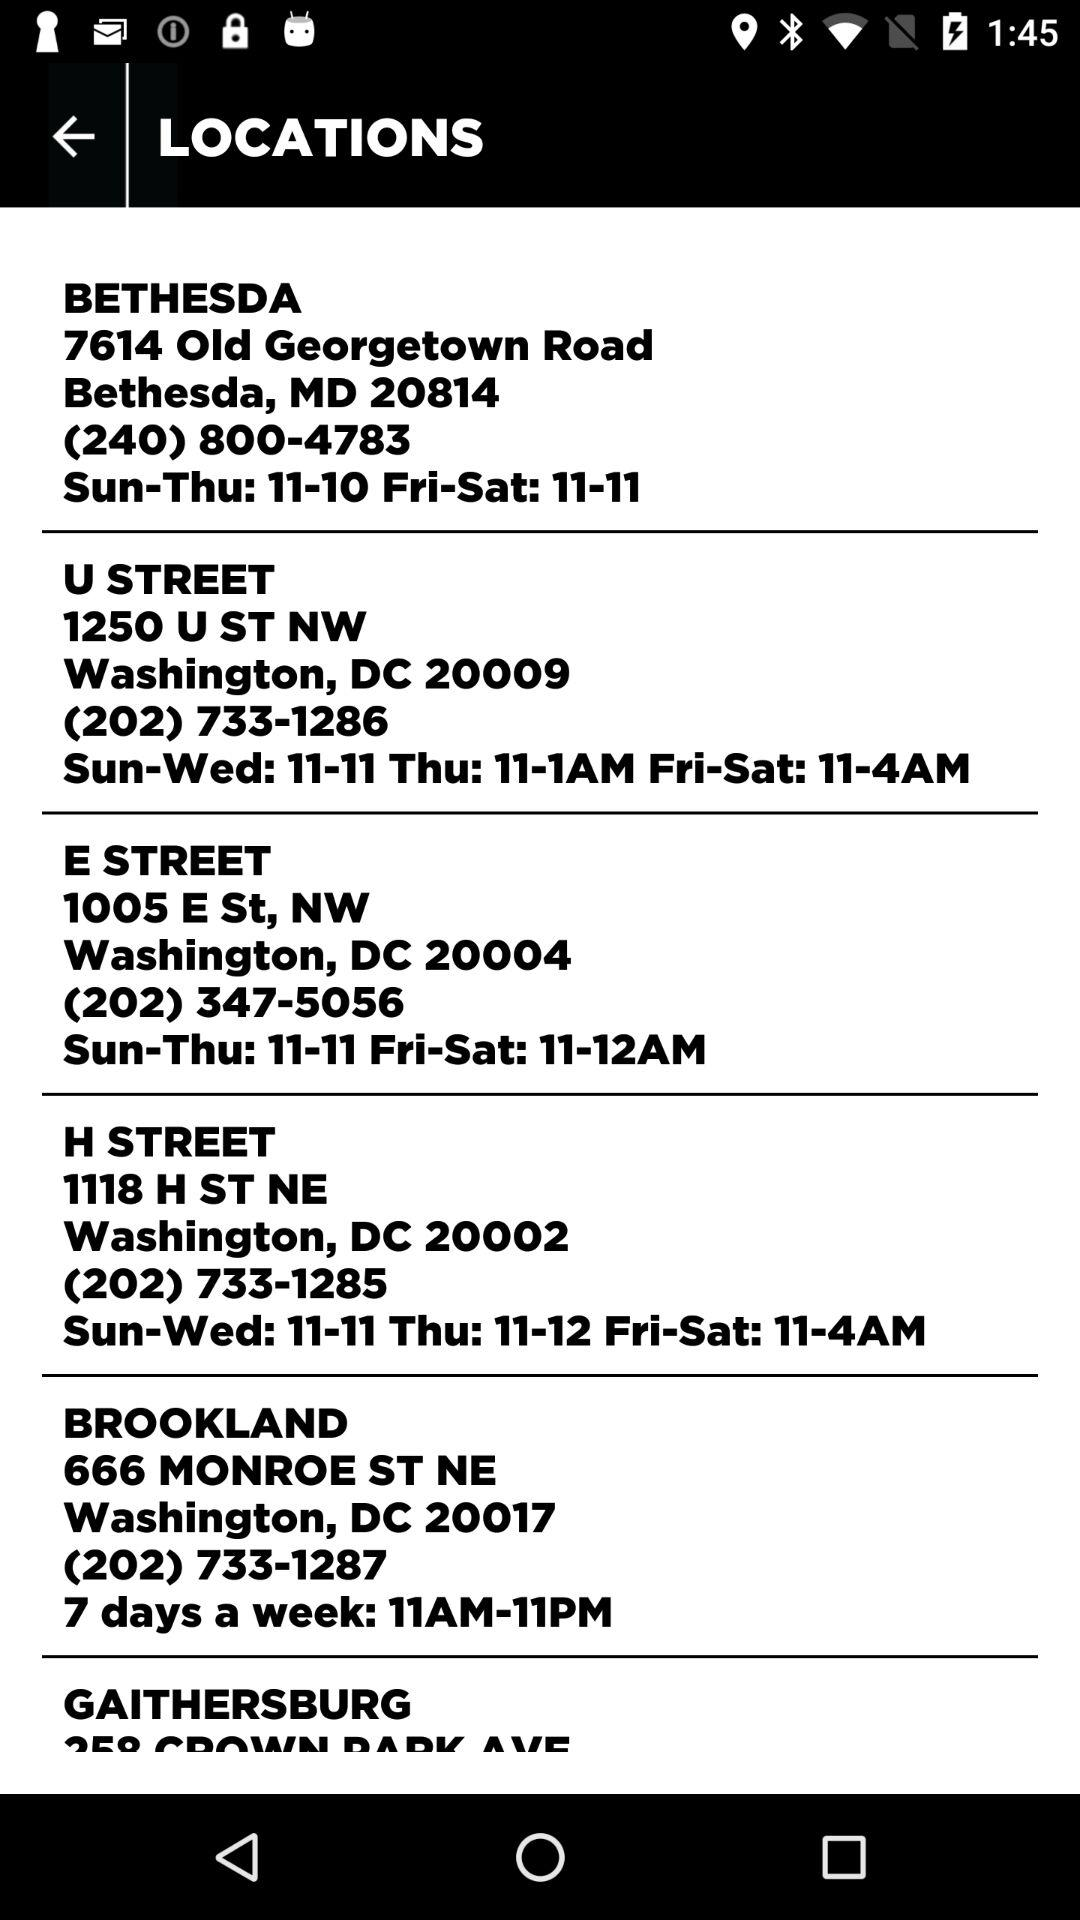What is the address of "H STREET"? The address is 1118 H ST NE, Washington, DC 20002. 